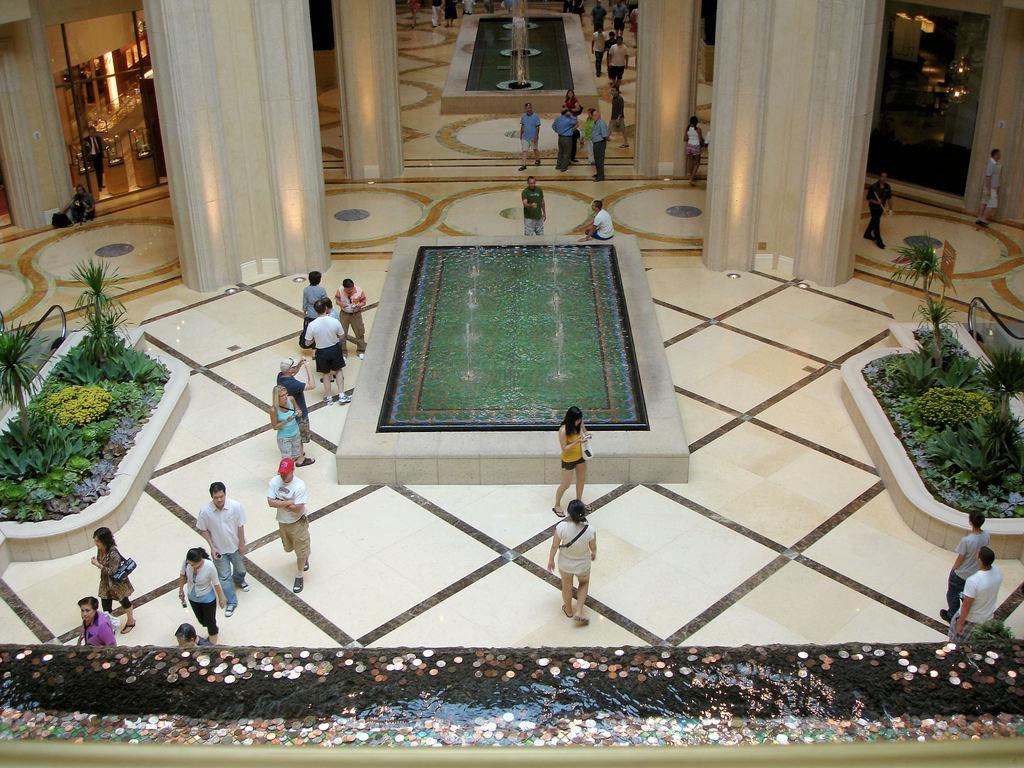Could you give a brief overview of what you see in this image? In this picture, it seems like decoration at the bottom side, there are fountains, people, plants, pillars, a door and light in the image. 